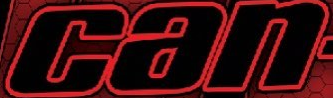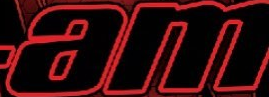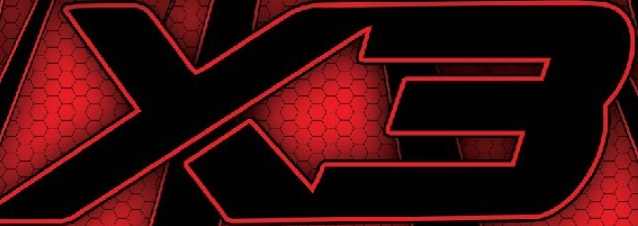Read the text content from these images in order, separated by a semicolon. can; am; X3 